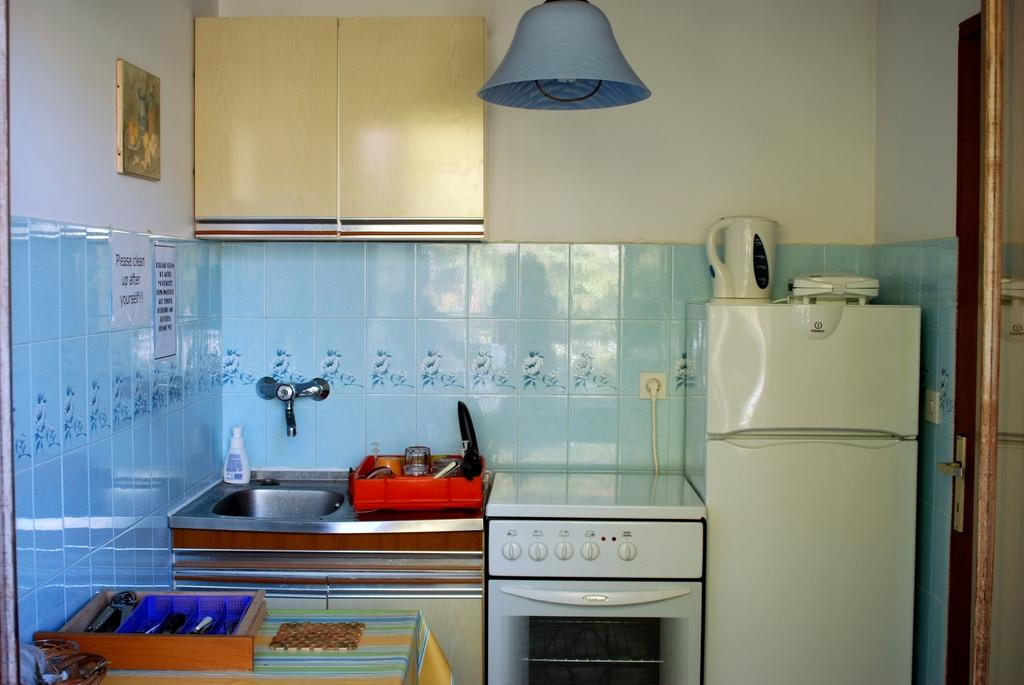Provide a one-sentence caption for the provided image. A kitchen with signs to the left of the fridge stating to clean up after yourself. 